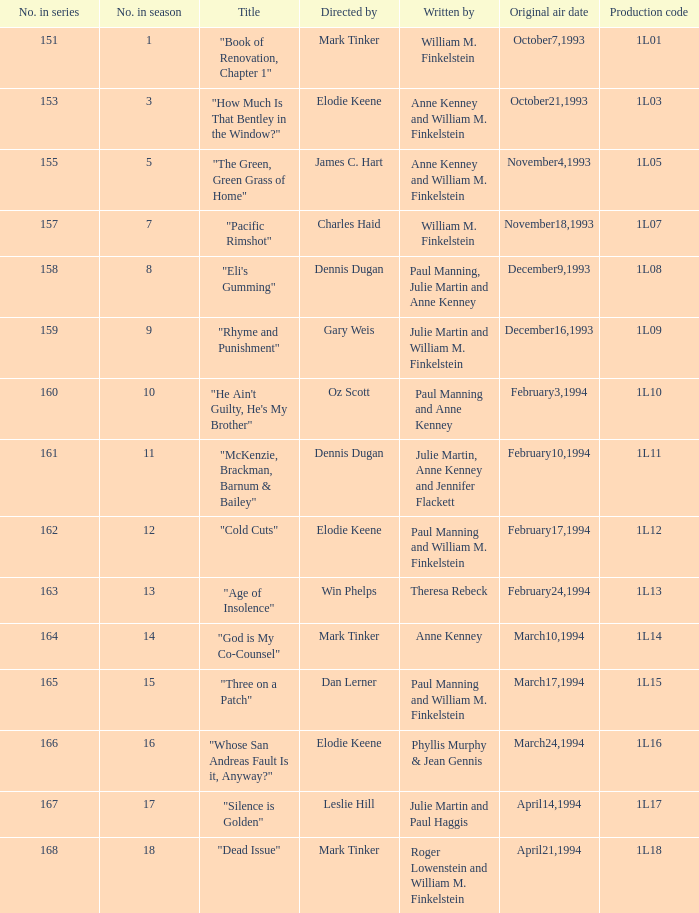Name the most number in season for leslie hill 17.0. 